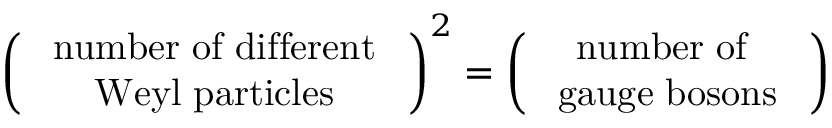Convert formula to latex. <formula><loc_0><loc_0><loc_500><loc_500>\left ( \begin{array} { c } { { { n u m b e r o f d i f f e r e n t } } } \\ { { { W e y l p a r t i c l e s } } } \end{array} \right ) ^ { 2 } = \left ( \begin{array} { c } { { { n u m b e r o f } } } \\ { { { g a u g e b o s o n s } } } \end{array} \right )</formula> 